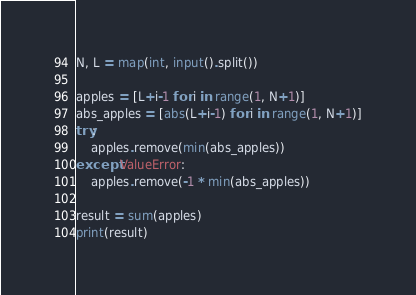Convert code to text. <code><loc_0><loc_0><loc_500><loc_500><_Python_>N, L = map(int, input().split())

apples = [L+i-1 for i in range(1, N+1)]
abs_apples = [abs(L+i-1) for i in range(1, N+1)]
try:
    apples.remove(min(abs_apples))
except ValueError:
    apples.remove(-1 * min(abs_apples))

result = sum(apples)
print(result)
</code> 